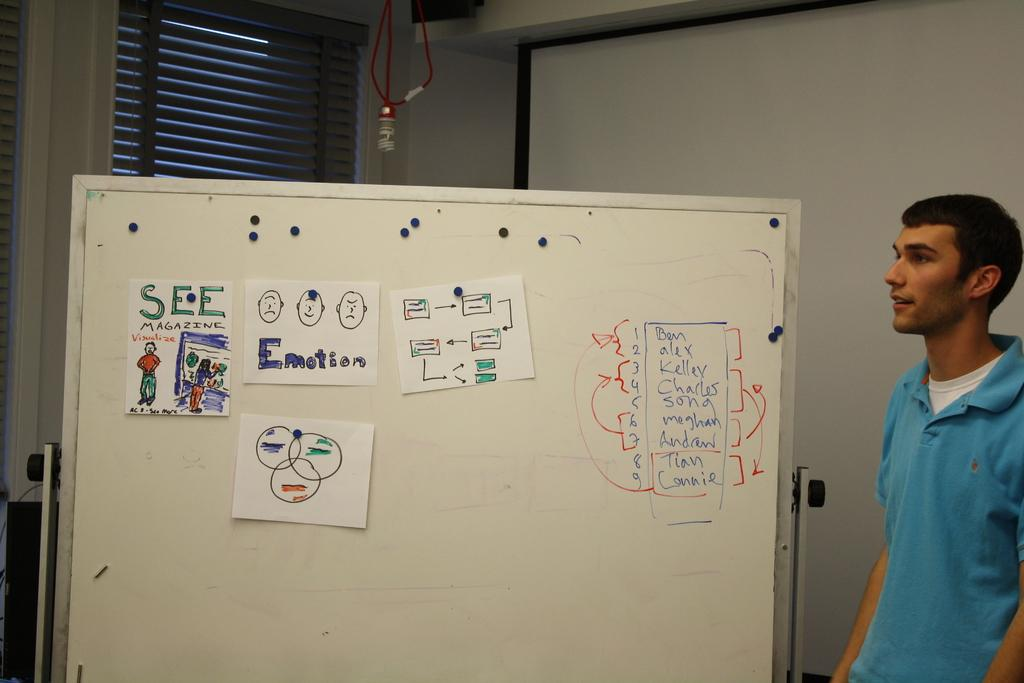<image>
Share a concise interpretation of the image provided. A man in front of a whiteboard with the word See visible on it. 